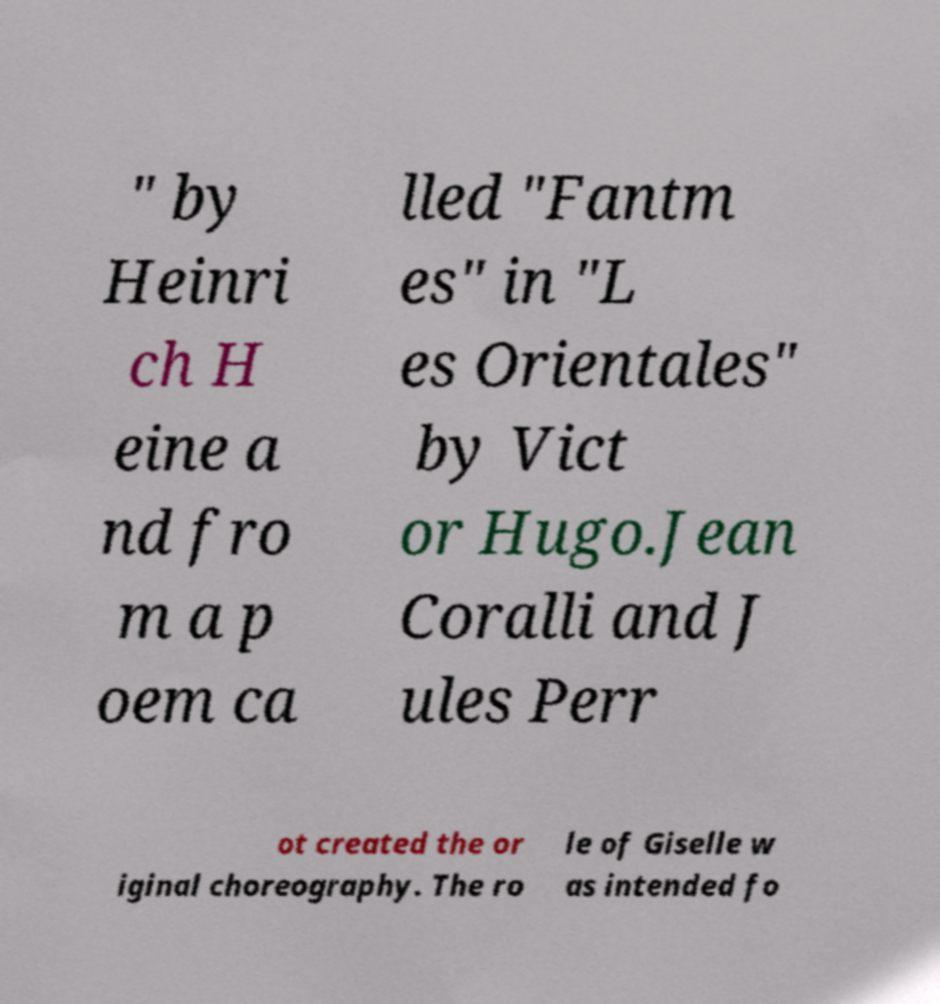For documentation purposes, I need the text within this image transcribed. Could you provide that? " by Heinri ch H eine a nd fro m a p oem ca lled "Fantm es" in "L es Orientales" by Vict or Hugo.Jean Coralli and J ules Perr ot created the or iginal choreography. The ro le of Giselle w as intended fo 